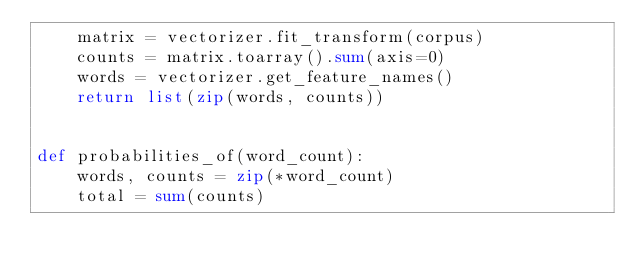<code> <loc_0><loc_0><loc_500><loc_500><_Python_>    matrix = vectorizer.fit_transform(corpus)
    counts = matrix.toarray().sum(axis=0)
    words = vectorizer.get_feature_names()
    return list(zip(words, counts))


def probabilities_of(word_count):
    words, counts = zip(*word_count)
    total = sum(counts)</code> 